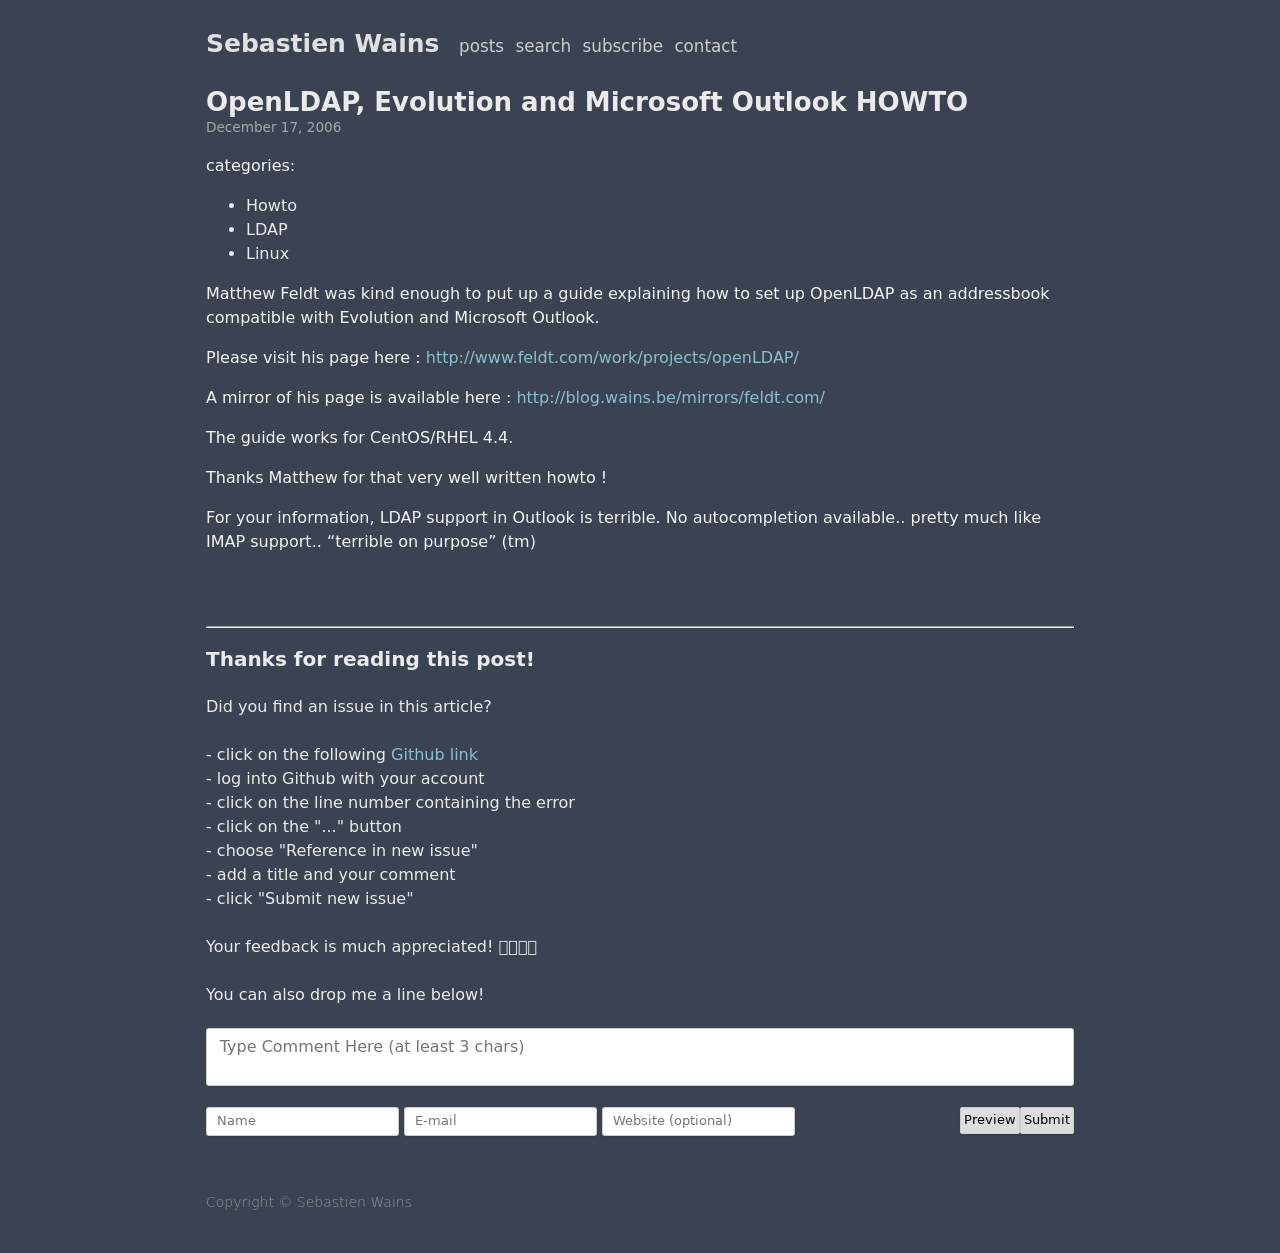Can you suggest some resources or tools that are useful for beginners in web development? Absolutely! For beginners in web development, some useful resources include: W3Schools for tutorials, Codecademy for interactive learning, Mozilla Developer Network (MDN) for comprehensive references and guides, and freeCodeCamp for structured learning paths and projects. Tools like Visual Studio Code, a code editor, and Google Chrome's Developer Tools for debugging, are also invaluable. 